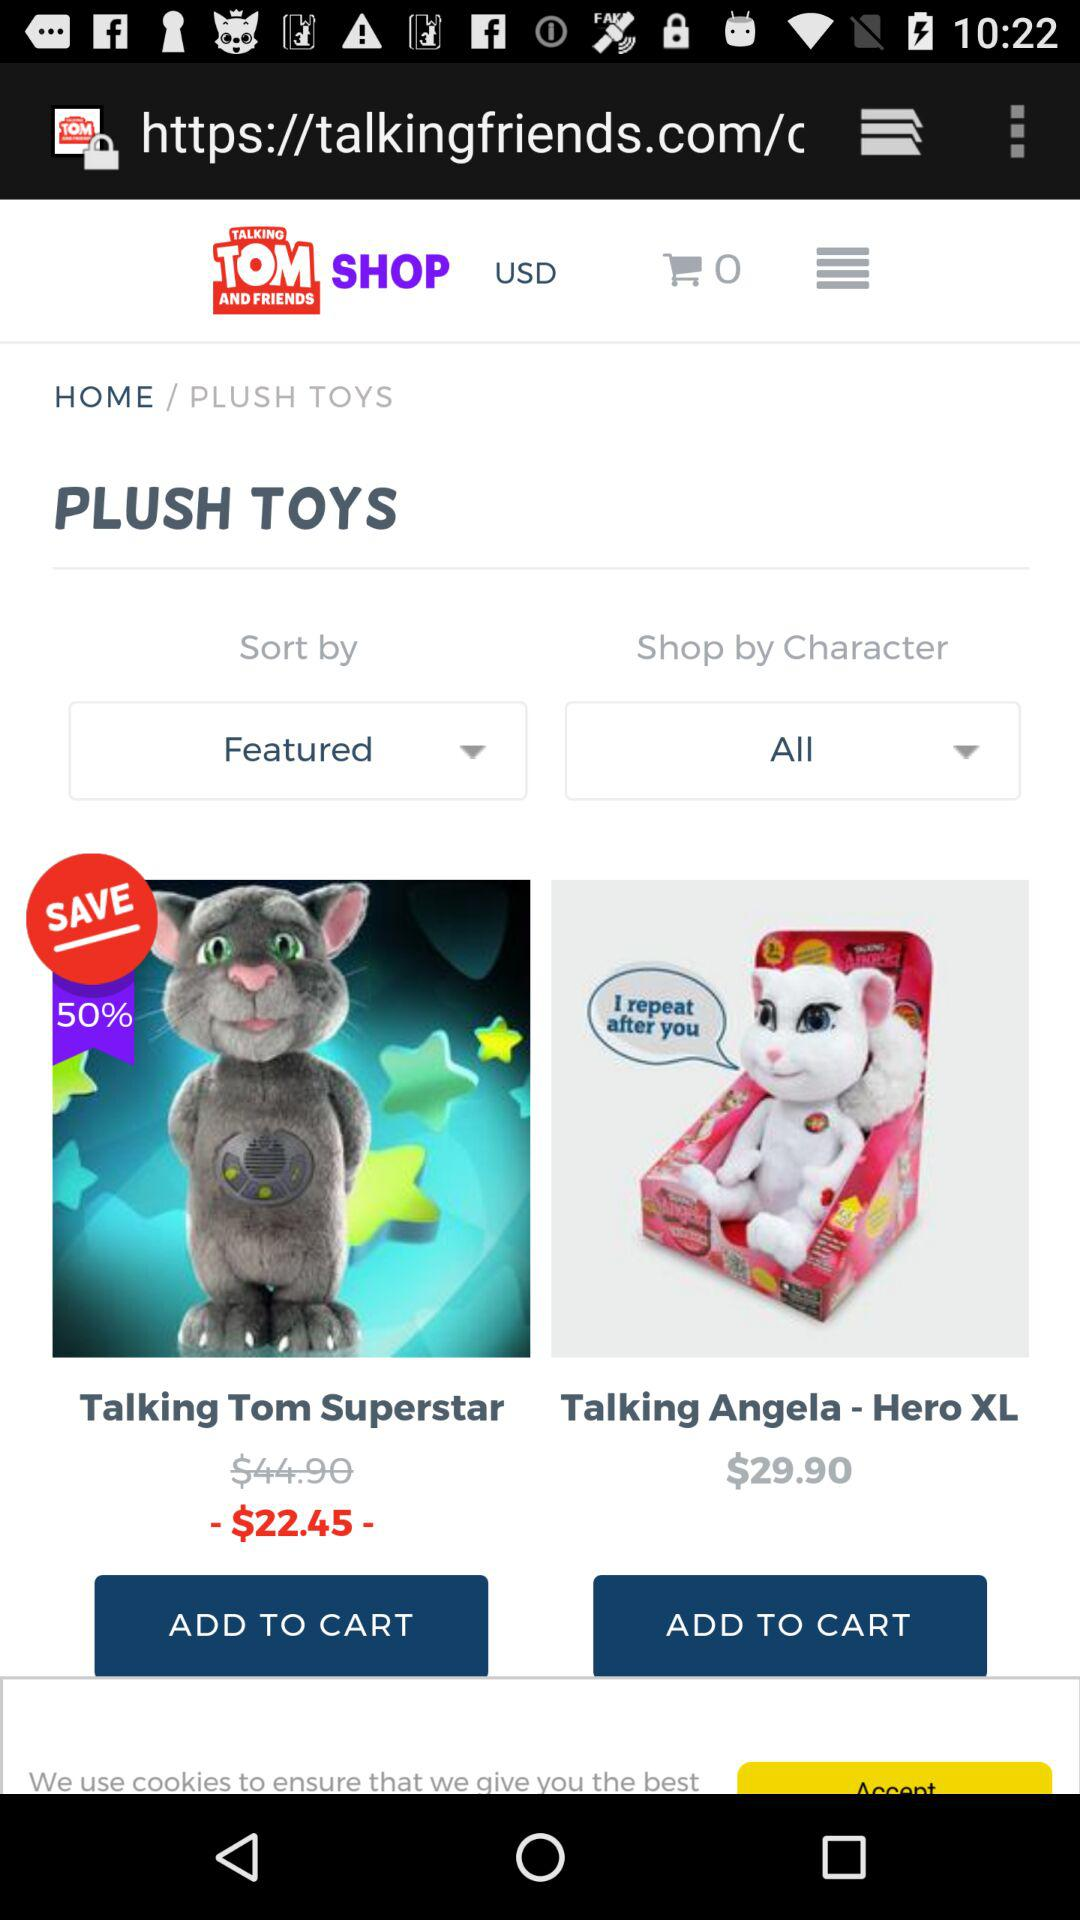How many items are added to the cart? There are 0 items. 